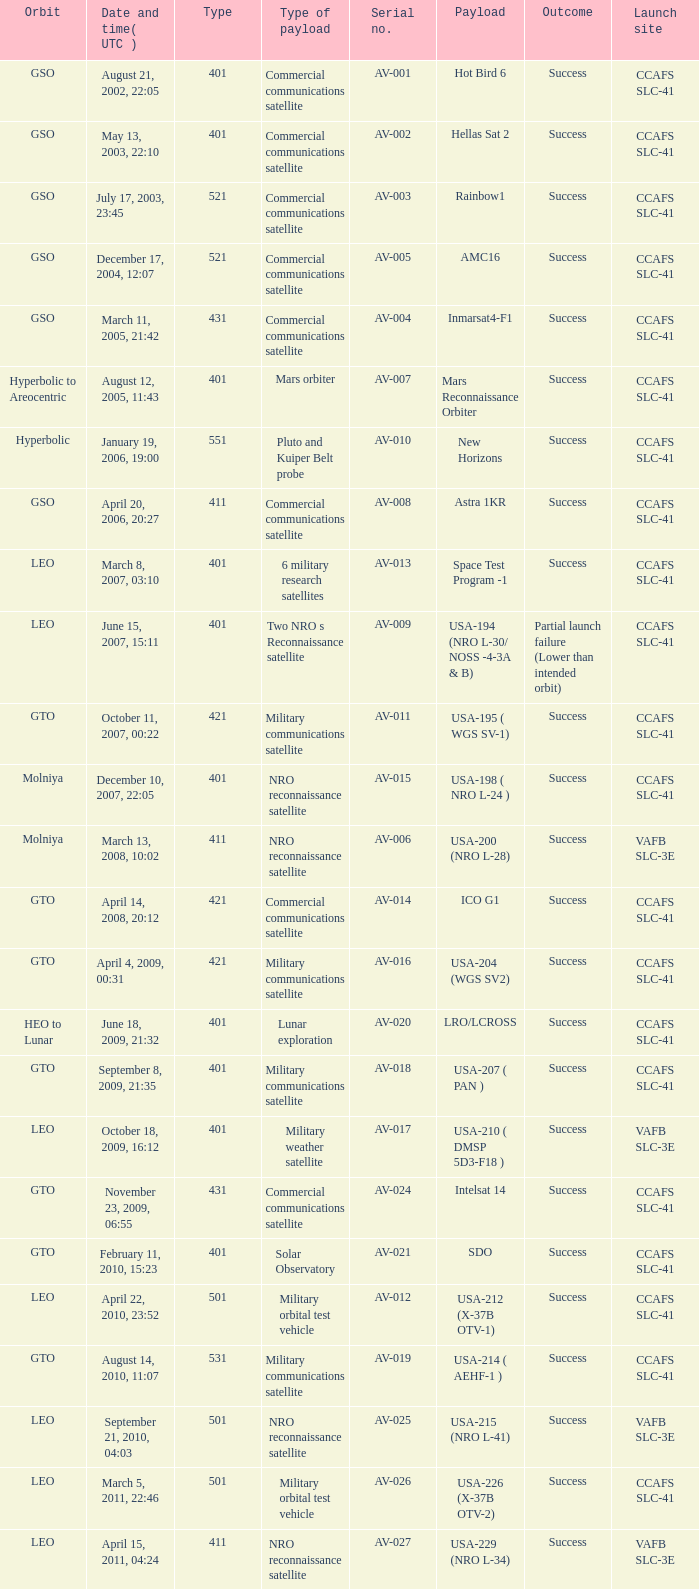What payload was on November 26, 2011, 15:02? Mars rover. 